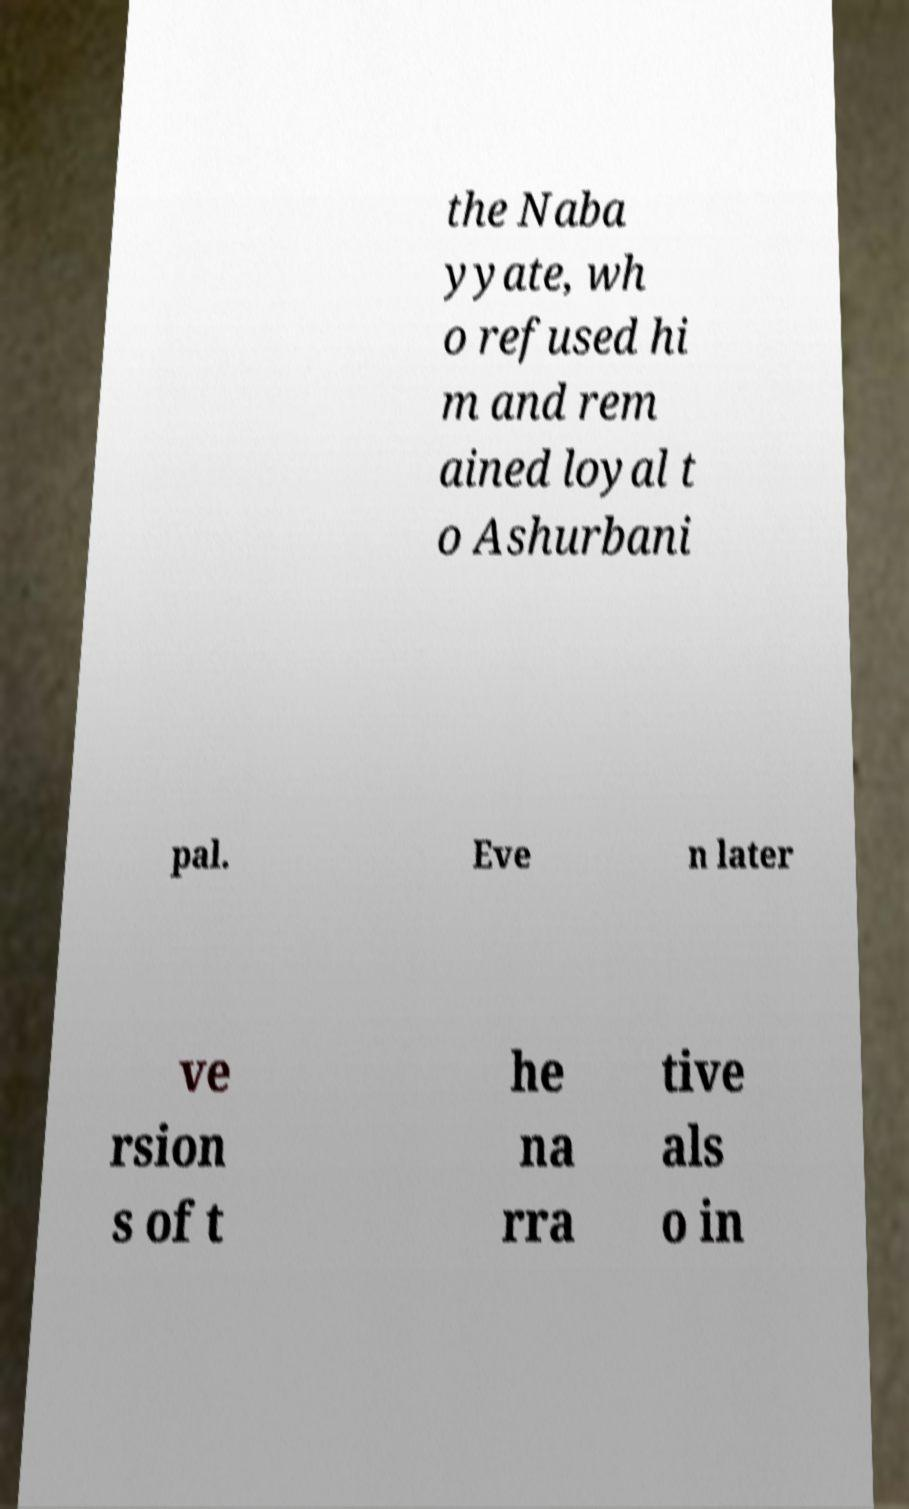Could you assist in decoding the text presented in this image and type it out clearly? the Naba yyate, wh o refused hi m and rem ained loyal t o Ashurbani pal. Eve n later ve rsion s of t he na rra tive als o in 